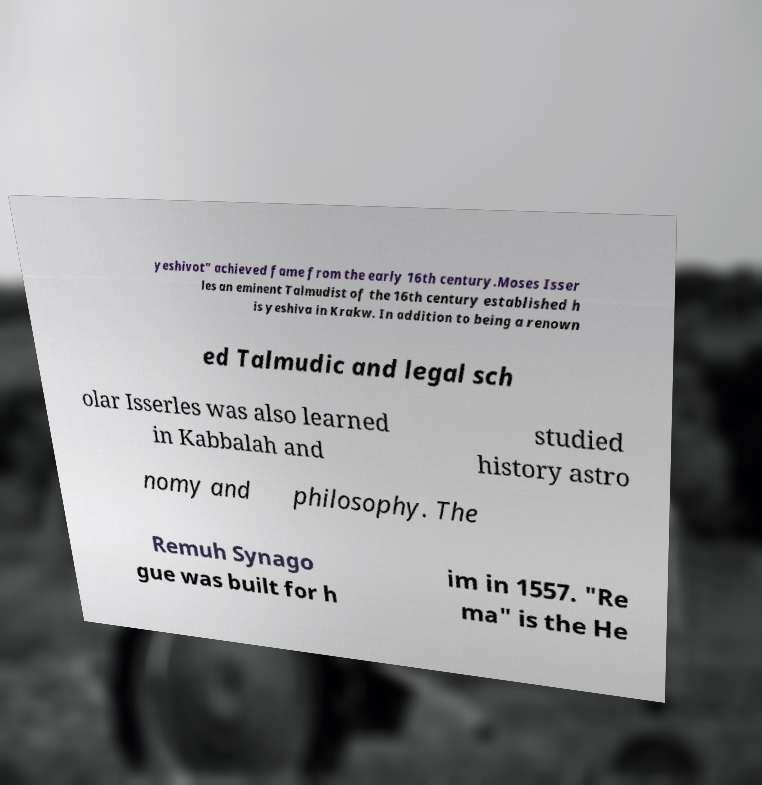Could you extract and type out the text from this image? yeshivot" achieved fame from the early 16th century.Moses Isser les an eminent Talmudist of the 16th century established h is yeshiva in Krakw. In addition to being a renown ed Talmudic and legal sch olar Isserles was also learned in Kabbalah and studied history astro nomy and philosophy. The Remuh Synago gue was built for h im in 1557. "Re ma" is the He 